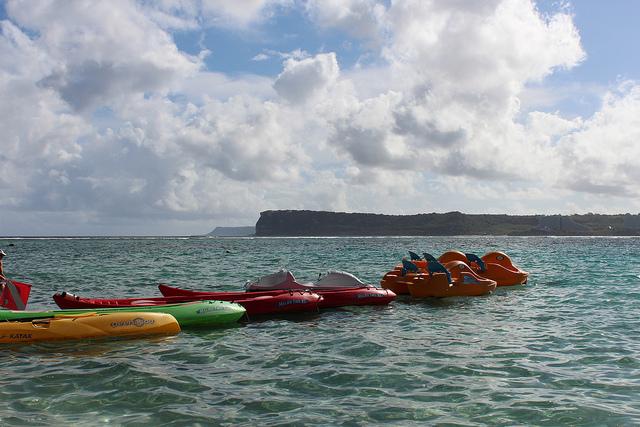Could these ships be used for long ocean voyages?
Short answer required. No. Is the sinking?
Short answer required. No. Are any of these paddle boats?
Keep it brief. Yes. What is orange in the water?
Answer briefly. Paddle boat. Is it a clear day?
Write a very short answer. No. 